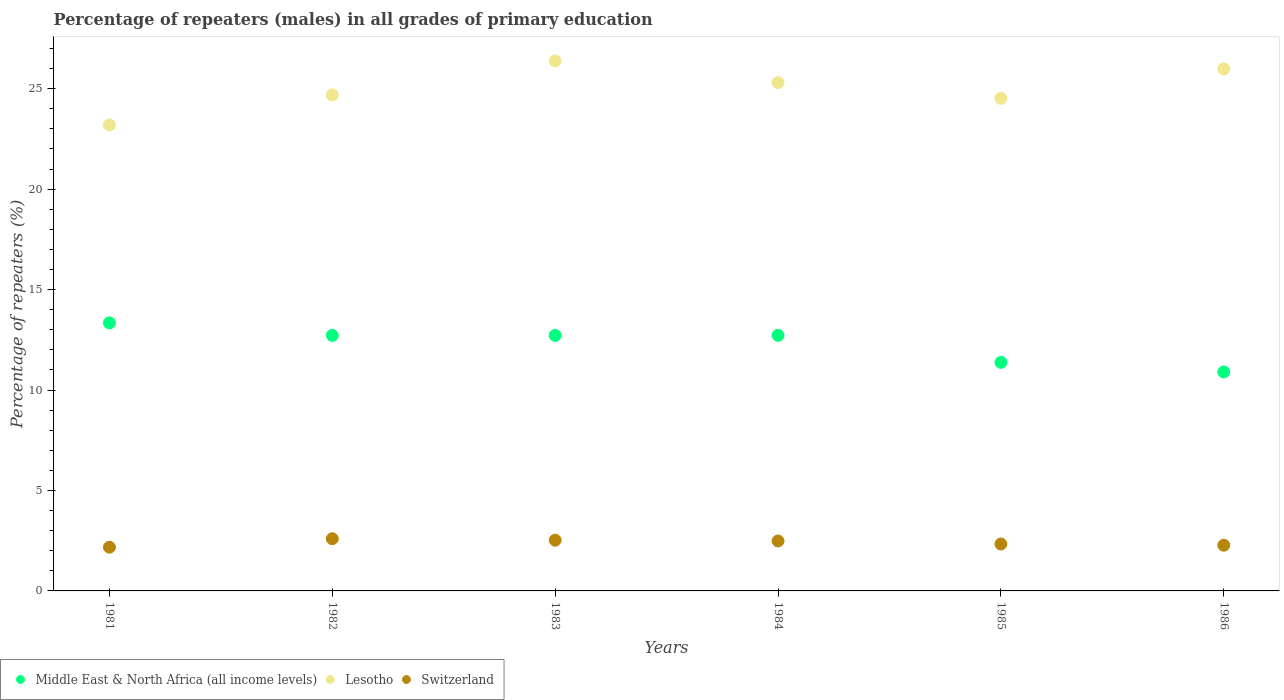Is the number of dotlines equal to the number of legend labels?
Make the answer very short. Yes. What is the percentage of repeaters (males) in Lesotho in 1981?
Your response must be concise. 23.2. Across all years, what is the maximum percentage of repeaters (males) in Switzerland?
Provide a short and direct response. 2.6. Across all years, what is the minimum percentage of repeaters (males) in Lesotho?
Your answer should be compact. 23.2. In which year was the percentage of repeaters (males) in Lesotho maximum?
Make the answer very short. 1983. What is the total percentage of repeaters (males) in Switzerland in the graph?
Keep it short and to the point. 14.4. What is the difference between the percentage of repeaters (males) in Switzerland in 1981 and that in 1985?
Offer a very short reply. -0.16. What is the difference between the percentage of repeaters (males) in Lesotho in 1985 and the percentage of repeaters (males) in Middle East & North Africa (all income levels) in 1981?
Make the answer very short. 11.18. What is the average percentage of repeaters (males) in Middle East & North Africa (all income levels) per year?
Give a very brief answer. 12.3. In the year 1986, what is the difference between the percentage of repeaters (males) in Lesotho and percentage of repeaters (males) in Middle East & North Africa (all income levels)?
Your answer should be very brief. 15.08. What is the ratio of the percentage of repeaters (males) in Switzerland in 1981 to that in 1986?
Give a very brief answer. 0.96. Is the percentage of repeaters (males) in Lesotho in 1985 less than that in 1986?
Provide a short and direct response. Yes. Is the difference between the percentage of repeaters (males) in Lesotho in 1983 and 1986 greater than the difference between the percentage of repeaters (males) in Middle East & North Africa (all income levels) in 1983 and 1986?
Provide a succinct answer. No. What is the difference between the highest and the second highest percentage of repeaters (males) in Lesotho?
Your response must be concise. 0.4. What is the difference between the highest and the lowest percentage of repeaters (males) in Middle East & North Africa (all income levels)?
Provide a succinct answer. 2.44. In how many years, is the percentage of repeaters (males) in Middle East & North Africa (all income levels) greater than the average percentage of repeaters (males) in Middle East & North Africa (all income levels) taken over all years?
Provide a short and direct response. 4. Is it the case that in every year, the sum of the percentage of repeaters (males) in Switzerland and percentage of repeaters (males) in Middle East & North Africa (all income levels)  is greater than the percentage of repeaters (males) in Lesotho?
Give a very brief answer. No. Does the percentage of repeaters (males) in Middle East & North Africa (all income levels) monotonically increase over the years?
Keep it short and to the point. No. Is the percentage of repeaters (males) in Lesotho strictly greater than the percentage of repeaters (males) in Middle East & North Africa (all income levels) over the years?
Your answer should be compact. Yes. Is the percentage of repeaters (males) in Middle East & North Africa (all income levels) strictly less than the percentage of repeaters (males) in Lesotho over the years?
Provide a succinct answer. Yes. How many dotlines are there?
Your response must be concise. 3. What is the difference between two consecutive major ticks on the Y-axis?
Your answer should be very brief. 5. Are the values on the major ticks of Y-axis written in scientific E-notation?
Your answer should be compact. No. Where does the legend appear in the graph?
Provide a succinct answer. Bottom left. How many legend labels are there?
Provide a succinct answer. 3. What is the title of the graph?
Give a very brief answer. Percentage of repeaters (males) in all grades of primary education. Does "Papua New Guinea" appear as one of the legend labels in the graph?
Give a very brief answer. No. What is the label or title of the X-axis?
Provide a succinct answer. Years. What is the label or title of the Y-axis?
Ensure brevity in your answer.  Percentage of repeaters (%). What is the Percentage of repeaters (%) in Middle East & North Africa (all income levels) in 1981?
Offer a very short reply. 13.34. What is the Percentage of repeaters (%) in Lesotho in 1981?
Provide a short and direct response. 23.2. What is the Percentage of repeaters (%) in Switzerland in 1981?
Make the answer very short. 2.18. What is the Percentage of repeaters (%) of Middle East & North Africa (all income levels) in 1982?
Offer a terse response. 12.72. What is the Percentage of repeaters (%) in Lesotho in 1982?
Keep it short and to the point. 24.69. What is the Percentage of repeaters (%) of Switzerland in 1982?
Keep it short and to the point. 2.6. What is the Percentage of repeaters (%) of Middle East & North Africa (all income levels) in 1983?
Give a very brief answer. 12.72. What is the Percentage of repeaters (%) in Lesotho in 1983?
Provide a succinct answer. 26.39. What is the Percentage of repeaters (%) of Switzerland in 1983?
Provide a short and direct response. 2.53. What is the Percentage of repeaters (%) in Middle East & North Africa (all income levels) in 1984?
Your answer should be very brief. 12.72. What is the Percentage of repeaters (%) of Lesotho in 1984?
Your answer should be very brief. 25.3. What is the Percentage of repeaters (%) of Switzerland in 1984?
Provide a short and direct response. 2.49. What is the Percentage of repeaters (%) in Middle East & North Africa (all income levels) in 1985?
Provide a succinct answer. 11.38. What is the Percentage of repeaters (%) of Lesotho in 1985?
Keep it short and to the point. 24.52. What is the Percentage of repeaters (%) of Switzerland in 1985?
Ensure brevity in your answer.  2.34. What is the Percentage of repeaters (%) in Middle East & North Africa (all income levels) in 1986?
Ensure brevity in your answer.  10.9. What is the Percentage of repeaters (%) of Lesotho in 1986?
Give a very brief answer. 25.98. What is the Percentage of repeaters (%) of Switzerland in 1986?
Your answer should be very brief. 2.28. Across all years, what is the maximum Percentage of repeaters (%) in Middle East & North Africa (all income levels)?
Provide a succinct answer. 13.34. Across all years, what is the maximum Percentage of repeaters (%) of Lesotho?
Make the answer very short. 26.39. Across all years, what is the maximum Percentage of repeaters (%) in Switzerland?
Offer a very short reply. 2.6. Across all years, what is the minimum Percentage of repeaters (%) in Middle East & North Africa (all income levels)?
Offer a very short reply. 10.9. Across all years, what is the minimum Percentage of repeaters (%) in Lesotho?
Your answer should be compact. 23.2. Across all years, what is the minimum Percentage of repeaters (%) of Switzerland?
Your answer should be compact. 2.18. What is the total Percentage of repeaters (%) of Middle East & North Africa (all income levels) in the graph?
Provide a succinct answer. 73.78. What is the total Percentage of repeaters (%) of Lesotho in the graph?
Offer a very short reply. 150.08. What is the total Percentage of repeaters (%) of Switzerland in the graph?
Give a very brief answer. 14.4. What is the difference between the Percentage of repeaters (%) in Middle East & North Africa (all income levels) in 1981 and that in 1982?
Keep it short and to the point. 0.62. What is the difference between the Percentage of repeaters (%) in Lesotho in 1981 and that in 1982?
Keep it short and to the point. -1.5. What is the difference between the Percentage of repeaters (%) in Switzerland in 1981 and that in 1982?
Make the answer very short. -0.42. What is the difference between the Percentage of repeaters (%) of Middle East & North Africa (all income levels) in 1981 and that in 1983?
Give a very brief answer. 0.62. What is the difference between the Percentage of repeaters (%) of Lesotho in 1981 and that in 1983?
Ensure brevity in your answer.  -3.19. What is the difference between the Percentage of repeaters (%) in Switzerland in 1981 and that in 1983?
Give a very brief answer. -0.35. What is the difference between the Percentage of repeaters (%) in Middle East & North Africa (all income levels) in 1981 and that in 1984?
Ensure brevity in your answer.  0.62. What is the difference between the Percentage of repeaters (%) of Lesotho in 1981 and that in 1984?
Your answer should be compact. -2.11. What is the difference between the Percentage of repeaters (%) of Switzerland in 1981 and that in 1984?
Provide a short and direct response. -0.31. What is the difference between the Percentage of repeaters (%) of Middle East & North Africa (all income levels) in 1981 and that in 1985?
Your answer should be very brief. 1.96. What is the difference between the Percentage of repeaters (%) of Lesotho in 1981 and that in 1985?
Offer a very short reply. -1.33. What is the difference between the Percentage of repeaters (%) of Switzerland in 1981 and that in 1985?
Your answer should be compact. -0.16. What is the difference between the Percentage of repeaters (%) of Middle East & North Africa (all income levels) in 1981 and that in 1986?
Your answer should be compact. 2.44. What is the difference between the Percentage of repeaters (%) in Lesotho in 1981 and that in 1986?
Your response must be concise. -2.79. What is the difference between the Percentage of repeaters (%) in Switzerland in 1981 and that in 1986?
Provide a short and direct response. -0.1. What is the difference between the Percentage of repeaters (%) of Middle East & North Africa (all income levels) in 1982 and that in 1983?
Offer a very short reply. 0. What is the difference between the Percentage of repeaters (%) in Lesotho in 1982 and that in 1983?
Ensure brevity in your answer.  -1.69. What is the difference between the Percentage of repeaters (%) of Switzerland in 1982 and that in 1983?
Make the answer very short. 0.07. What is the difference between the Percentage of repeaters (%) in Middle East & North Africa (all income levels) in 1982 and that in 1984?
Make the answer very short. -0. What is the difference between the Percentage of repeaters (%) of Lesotho in 1982 and that in 1984?
Give a very brief answer. -0.61. What is the difference between the Percentage of repeaters (%) of Switzerland in 1982 and that in 1984?
Your answer should be compact. 0.11. What is the difference between the Percentage of repeaters (%) in Middle East & North Africa (all income levels) in 1982 and that in 1985?
Provide a short and direct response. 1.34. What is the difference between the Percentage of repeaters (%) of Lesotho in 1982 and that in 1985?
Your answer should be very brief. 0.17. What is the difference between the Percentage of repeaters (%) of Switzerland in 1982 and that in 1985?
Your response must be concise. 0.26. What is the difference between the Percentage of repeaters (%) of Middle East & North Africa (all income levels) in 1982 and that in 1986?
Your response must be concise. 1.82. What is the difference between the Percentage of repeaters (%) in Lesotho in 1982 and that in 1986?
Provide a succinct answer. -1.29. What is the difference between the Percentage of repeaters (%) of Switzerland in 1982 and that in 1986?
Offer a terse response. 0.32. What is the difference between the Percentage of repeaters (%) in Middle East & North Africa (all income levels) in 1983 and that in 1984?
Provide a succinct answer. -0.01. What is the difference between the Percentage of repeaters (%) in Lesotho in 1983 and that in 1984?
Provide a short and direct response. 1.08. What is the difference between the Percentage of repeaters (%) of Switzerland in 1983 and that in 1984?
Offer a terse response. 0.04. What is the difference between the Percentage of repeaters (%) of Middle East & North Africa (all income levels) in 1983 and that in 1985?
Your response must be concise. 1.34. What is the difference between the Percentage of repeaters (%) of Lesotho in 1983 and that in 1985?
Your answer should be very brief. 1.86. What is the difference between the Percentage of repeaters (%) of Switzerland in 1983 and that in 1985?
Provide a succinct answer. 0.19. What is the difference between the Percentage of repeaters (%) of Middle East & North Africa (all income levels) in 1983 and that in 1986?
Your answer should be very brief. 1.82. What is the difference between the Percentage of repeaters (%) in Lesotho in 1983 and that in 1986?
Give a very brief answer. 0.4. What is the difference between the Percentage of repeaters (%) in Switzerland in 1983 and that in 1986?
Keep it short and to the point. 0.25. What is the difference between the Percentage of repeaters (%) of Middle East & North Africa (all income levels) in 1984 and that in 1985?
Keep it short and to the point. 1.35. What is the difference between the Percentage of repeaters (%) in Lesotho in 1984 and that in 1985?
Give a very brief answer. 0.78. What is the difference between the Percentage of repeaters (%) of Switzerland in 1984 and that in 1985?
Give a very brief answer. 0.15. What is the difference between the Percentage of repeaters (%) of Middle East & North Africa (all income levels) in 1984 and that in 1986?
Provide a succinct answer. 1.82. What is the difference between the Percentage of repeaters (%) of Lesotho in 1984 and that in 1986?
Offer a terse response. -0.68. What is the difference between the Percentage of repeaters (%) in Switzerland in 1984 and that in 1986?
Your answer should be compact. 0.21. What is the difference between the Percentage of repeaters (%) of Middle East & North Africa (all income levels) in 1985 and that in 1986?
Your answer should be compact. 0.48. What is the difference between the Percentage of repeaters (%) of Lesotho in 1985 and that in 1986?
Your answer should be compact. -1.46. What is the difference between the Percentage of repeaters (%) of Switzerland in 1985 and that in 1986?
Your answer should be compact. 0.06. What is the difference between the Percentage of repeaters (%) of Middle East & North Africa (all income levels) in 1981 and the Percentage of repeaters (%) of Lesotho in 1982?
Provide a short and direct response. -11.35. What is the difference between the Percentage of repeaters (%) in Middle East & North Africa (all income levels) in 1981 and the Percentage of repeaters (%) in Switzerland in 1982?
Provide a short and direct response. 10.74. What is the difference between the Percentage of repeaters (%) of Lesotho in 1981 and the Percentage of repeaters (%) of Switzerland in 1982?
Provide a short and direct response. 20.6. What is the difference between the Percentage of repeaters (%) in Middle East & North Africa (all income levels) in 1981 and the Percentage of repeaters (%) in Lesotho in 1983?
Give a very brief answer. -13.04. What is the difference between the Percentage of repeaters (%) in Middle East & North Africa (all income levels) in 1981 and the Percentage of repeaters (%) in Switzerland in 1983?
Provide a succinct answer. 10.82. What is the difference between the Percentage of repeaters (%) of Lesotho in 1981 and the Percentage of repeaters (%) of Switzerland in 1983?
Keep it short and to the point. 20.67. What is the difference between the Percentage of repeaters (%) of Middle East & North Africa (all income levels) in 1981 and the Percentage of repeaters (%) of Lesotho in 1984?
Provide a succinct answer. -11.96. What is the difference between the Percentage of repeaters (%) in Middle East & North Africa (all income levels) in 1981 and the Percentage of repeaters (%) in Switzerland in 1984?
Your response must be concise. 10.86. What is the difference between the Percentage of repeaters (%) of Lesotho in 1981 and the Percentage of repeaters (%) of Switzerland in 1984?
Provide a succinct answer. 20.71. What is the difference between the Percentage of repeaters (%) of Middle East & North Africa (all income levels) in 1981 and the Percentage of repeaters (%) of Lesotho in 1985?
Your answer should be very brief. -11.18. What is the difference between the Percentage of repeaters (%) in Middle East & North Africa (all income levels) in 1981 and the Percentage of repeaters (%) in Switzerland in 1985?
Your answer should be compact. 11.01. What is the difference between the Percentage of repeaters (%) in Lesotho in 1981 and the Percentage of repeaters (%) in Switzerland in 1985?
Offer a terse response. 20.86. What is the difference between the Percentage of repeaters (%) of Middle East & North Africa (all income levels) in 1981 and the Percentage of repeaters (%) of Lesotho in 1986?
Ensure brevity in your answer.  -12.64. What is the difference between the Percentage of repeaters (%) of Middle East & North Africa (all income levels) in 1981 and the Percentage of repeaters (%) of Switzerland in 1986?
Your answer should be very brief. 11.07. What is the difference between the Percentage of repeaters (%) in Lesotho in 1981 and the Percentage of repeaters (%) in Switzerland in 1986?
Your answer should be very brief. 20.92. What is the difference between the Percentage of repeaters (%) of Middle East & North Africa (all income levels) in 1982 and the Percentage of repeaters (%) of Lesotho in 1983?
Your answer should be compact. -13.67. What is the difference between the Percentage of repeaters (%) of Middle East & North Africa (all income levels) in 1982 and the Percentage of repeaters (%) of Switzerland in 1983?
Provide a short and direct response. 10.19. What is the difference between the Percentage of repeaters (%) in Lesotho in 1982 and the Percentage of repeaters (%) in Switzerland in 1983?
Offer a very short reply. 22.17. What is the difference between the Percentage of repeaters (%) of Middle East & North Africa (all income levels) in 1982 and the Percentage of repeaters (%) of Lesotho in 1984?
Offer a very short reply. -12.58. What is the difference between the Percentage of repeaters (%) in Middle East & North Africa (all income levels) in 1982 and the Percentage of repeaters (%) in Switzerland in 1984?
Your answer should be very brief. 10.23. What is the difference between the Percentage of repeaters (%) of Lesotho in 1982 and the Percentage of repeaters (%) of Switzerland in 1984?
Offer a very short reply. 22.21. What is the difference between the Percentage of repeaters (%) of Middle East & North Africa (all income levels) in 1982 and the Percentage of repeaters (%) of Lesotho in 1985?
Provide a short and direct response. -11.8. What is the difference between the Percentage of repeaters (%) of Middle East & North Africa (all income levels) in 1982 and the Percentage of repeaters (%) of Switzerland in 1985?
Your answer should be compact. 10.38. What is the difference between the Percentage of repeaters (%) in Lesotho in 1982 and the Percentage of repeaters (%) in Switzerland in 1985?
Give a very brief answer. 22.36. What is the difference between the Percentage of repeaters (%) of Middle East & North Africa (all income levels) in 1982 and the Percentage of repeaters (%) of Lesotho in 1986?
Ensure brevity in your answer.  -13.26. What is the difference between the Percentage of repeaters (%) of Middle East & North Africa (all income levels) in 1982 and the Percentage of repeaters (%) of Switzerland in 1986?
Keep it short and to the point. 10.44. What is the difference between the Percentage of repeaters (%) in Lesotho in 1982 and the Percentage of repeaters (%) in Switzerland in 1986?
Your answer should be very brief. 22.42. What is the difference between the Percentage of repeaters (%) in Middle East & North Africa (all income levels) in 1983 and the Percentage of repeaters (%) in Lesotho in 1984?
Give a very brief answer. -12.58. What is the difference between the Percentage of repeaters (%) of Middle East & North Africa (all income levels) in 1983 and the Percentage of repeaters (%) of Switzerland in 1984?
Your answer should be compact. 10.23. What is the difference between the Percentage of repeaters (%) of Lesotho in 1983 and the Percentage of repeaters (%) of Switzerland in 1984?
Provide a succinct answer. 23.9. What is the difference between the Percentage of repeaters (%) in Middle East & North Africa (all income levels) in 1983 and the Percentage of repeaters (%) in Lesotho in 1985?
Give a very brief answer. -11.8. What is the difference between the Percentage of repeaters (%) in Middle East & North Africa (all income levels) in 1983 and the Percentage of repeaters (%) in Switzerland in 1985?
Make the answer very short. 10.38. What is the difference between the Percentage of repeaters (%) in Lesotho in 1983 and the Percentage of repeaters (%) in Switzerland in 1985?
Keep it short and to the point. 24.05. What is the difference between the Percentage of repeaters (%) of Middle East & North Africa (all income levels) in 1983 and the Percentage of repeaters (%) of Lesotho in 1986?
Provide a succinct answer. -13.27. What is the difference between the Percentage of repeaters (%) in Middle East & North Africa (all income levels) in 1983 and the Percentage of repeaters (%) in Switzerland in 1986?
Ensure brevity in your answer.  10.44. What is the difference between the Percentage of repeaters (%) in Lesotho in 1983 and the Percentage of repeaters (%) in Switzerland in 1986?
Your response must be concise. 24.11. What is the difference between the Percentage of repeaters (%) of Middle East & North Africa (all income levels) in 1984 and the Percentage of repeaters (%) of Lesotho in 1985?
Ensure brevity in your answer.  -11.8. What is the difference between the Percentage of repeaters (%) of Middle East & North Africa (all income levels) in 1984 and the Percentage of repeaters (%) of Switzerland in 1985?
Ensure brevity in your answer.  10.39. What is the difference between the Percentage of repeaters (%) in Lesotho in 1984 and the Percentage of repeaters (%) in Switzerland in 1985?
Provide a succinct answer. 22.97. What is the difference between the Percentage of repeaters (%) of Middle East & North Africa (all income levels) in 1984 and the Percentage of repeaters (%) of Lesotho in 1986?
Keep it short and to the point. -13.26. What is the difference between the Percentage of repeaters (%) of Middle East & North Africa (all income levels) in 1984 and the Percentage of repeaters (%) of Switzerland in 1986?
Provide a succinct answer. 10.45. What is the difference between the Percentage of repeaters (%) in Lesotho in 1984 and the Percentage of repeaters (%) in Switzerland in 1986?
Your response must be concise. 23.03. What is the difference between the Percentage of repeaters (%) of Middle East & North Africa (all income levels) in 1985 and the Percentage of repeaters (%) of Lesotho in 1986?
Ensure brevity in your answer.  -14.61. What is the difference between the Percentage of repeaters (%) in Middle East & North Africa (all income levels) in 1985 and the Percentage of repeaters (%) in Switzerland in 1986?
Keep it short and to the point. 9.1. What is the difference between the Percentage of repeaters (%) of Lesotho in 1985 and the Percentage of repeaters (%) of Switzerland in 1986?
Ensure brevity in your answer.  22.25. What is the average Percentage of repeaters (%) of Middle East & North Africa (all income levels) per year?
Offer a terse response. 12.3. What is the average Percentage of repeaters (%) of Lesotho per year?
Your response must be concise. 25.01. In the year 1981, what is the difference between the Percentage of repeaters (%) of Middle East & North Africa (all income levels) and Percentage of repeaters (%) of Lesotho?
Keep it short and to the point. -9.85. In the year 1981, what is the difference between the Percentage of repeaters (%) of Middle East & North Africa (all income levels) and Percentage of repeaters (%) of Switzerland?
Your answer should be compact. 11.17. In the year 1981, what is the difference between the Percentage of repeaters (%) in Lesotho and Percentage of repeaters (%) in Switzerland?
Your answer should be very brief. 21.02. In the year 1982, what is the difference between the Percentage of repeaters (%) in Middle East & North Africa (all income levels) and Percentage of repeaters (%) in Lesotho?
Provide a short and direct response. -11.97. In the year 1982, what is the difference between the Percentage of repeaters (%) in Middle East & North Africa (all income levels) and Percentage of repeaters (%) in Switzerland?
Your answer should be very brief. 10.12. In the year 1982, what is the difference between the Percentage of repeaters (%) of Lesotho and Percentage of repeaters (%) of Switzerland?
Give a very brief answer. 22.09. In the year 1983, what is the difference between the Percentage of repeaters (%) of Middle East & North Africa (all income levels) and Percentage of repeaters (%) of Lesotho?
Make the answer very short. -13.67. In the year 1983, what is the difference between the Percentage of repeaters (%) in Middle East & North Africa (all income levels) and Percentage of repeaters (%) in Switzerland?
Provide a succinct answer. 10.19. In the year 1983, what is the difference between the Percentage of repeaters (%) of Lesotho and Percentage of repeaters (%) of Switzerland?
Ensure brevity in your answer.  23.86. In the year 1984, what is the difference between the Percentage of repeaters (%) in Middle East & North Africa (all income levels) and Percentage of repeaters (%) in Lesotho?
Offer a terse response. -12.58. In the year 1984, what is the difference between the Percentage of repeaters (%) of Middle East & North Africa (all income levels) and Percentage of repeaters (%) of Switzerland?
Give a very brief answer. 10.24. In the year 1984, what is the difference between the Percentage of repeaters (%) of Lesotho and Percentage of repeaters (%) of Switzerland?
Your answer should be compact. 22.82. In the year 1985, what is the difference between the Percentage of repeaters (%) in Middle East & North Africa (all income levels) and Percentage of repeaters (%) in Lesotho?
Provide a succinct answer. -13.14. In the year 1985, what is the difference between the Percentage of repeaters (%) in Middle East & North Africa (all income levels) and Percentage of repeaters (%) in Switzerland?
Ensure brevity in your answer.  9.04. In the year 1985, what is the difference between the Percentage of repeaters (%) in Lesotho and Percentage of repeaters (%) in Switzerland?
Your response must be concise. 22.19. In the year 1986, what is the difference between the Percentage of repeaters (%) of Middle East & North Africa (all income levels) and Percentage of repeaters (%) of Lesotho?
Make the answer very short. -15.08. In the year 1986, what is the difference between the Percentage of repeaters (%) of Middle East & North Africa (all income levels) and Percentage of repeaters (%) of Switzerland?
Provide a short and direct response. 8.62. In the year 1986, what is the difference between the Percentage of repeaters (%) in Lesotho and Percentage of repeaters (%) in Switzerland?
Provide a short and direct response. 23.71. What is the ratio of the Percentage of repeaters (%) in Middle East & North Africa (all income levels) in 1981 to that in 1982?
Make the answer very short. 1.05. What is the ratio of the Percentage of repeaters (%) in Lesotho in 1981 to that in 1982?
Your answer should be compact. 0.94. What is the ratio of the Percentage of repeaters (%) of Switzerland in 1981 to that in 1982?
Give a very brief answer. 0.84. What is the ratio of the Percentage of repeaters (%) in Middle East & North Africa (all income levels) in 1981 to that in 1983?
Make the answer very short. 1.05. What is the ratio of the Percentage of repeaters (%) in Lesotho in 1981 to that in 1983?
Keep it short and to the point. 0.88. What is the ratio of the Percentage of repeaters (%) of Switzerland in 1981 to that in 1983?
Ensure brevity in your answer.  0.86. What is the ratio of the Percentage of repeaters (%) of Middle East & North Africa (all income levels) in 1981 to that in 1984?
Provide a short and direct response. 1.05. What is the ratio of the Percentage of repeaters (%) in Lesotho in 1981 to that in 1984?
Offer a terse response. 0.92. What is the ratio of the Percentage of repeaters (%) in Switzerland in 1981 to that in 1984?
Ensure brevity in your answer.  0.87. What is the ratio of the Percentage of repeaters (%) of Middle East & North Africa (all income levels) in 1981 to that in 1985?
Offer a terse response. 1.17. What is the ratio of the Percentage of repeaters (%) in Lesotho in 1981 to that in 1985?
Make the answer very short. 0.95. What is the ratio of the Percentage of repeaters (%) in Switzerland in 1981 to that in 1985?
Ensure brevity in your answer.  0.93. What is the ratio of the Percentage of repeaters (%) in Middle East & North Africa (all income levels) in 1981 to that in 1986?
Keep it short and to the point. 1.22. What is the ratio of the Percentage of repeaters (%) of Lesotho in 1981 to that in 1986?
Give a very brief answer. 0.89. What is the ratio of the Percentage of repeaters (%) in Switzerland in 1981 to that in 1986?
Your response must be concise. 0.96. What is the ratio of the Percentage of repeaters (%) in Lesotho in 1982 to that in 1983?
Ensure brevity in your answer.  0.94. What is the ratio of the Percentage of repeaters (%) in Switzerland in 1982 to that in 1983?
Your response must be concise. 1.03. What is the ratio of the Percentage of repeaters (%) of Lesotho in 1982 to that in 1984?
Give a very brief answer. 0.98. What is the ratio of the Percentage of repeaters (%) in Switzerland in 1982 to that in 1984?
Make the answer very short. 1.04. What is the ratio of the Percentage of repeaters (%) in Middle East & North Africa (all income levels) in 1982 to that in 1985?
Give a very brief answer. 1.12. What is the ratio of the Percentage of repeaters (%) in Lesotho in 1982 to that in 1985?
Give a very brief answer. 1.01. What is the ratio of the Percentage of repeaters (%) in Switzerland in 1982 to that in 1985?
Give a very brief answer. 1.11. What is the ratio of the Percentage of repeaters (%) of Middle East & North Africa (all income levels) in 1982 to that in 1986?
Give a very brief answer. 1.17. What is the ratio of the Percentage of repeaters (%) in Lesotho in 1982 to that in 1986?
Your answer should be compact. 0.95. What is the ratio of the Percentage of repeaters (%) in Switzerland in 1982 to that in 1986?
Ensure brevity in your answer.  1.14. What is the ratio of the Percentage of repeaters (%) of Middle East & North Africa (all income levels) in 1983 to that in 1984?
Offer a terse response. 1. What is the ratio of the Percentage of repeaters (%) in Lesotho in 1983 to that in 1984?
Your answer should be very brief. 1.04. What is the ratio of the Percentage of repeaters (%) of Switzerland in 1983 to that in 1984?
Your answer should be compact. 1.02. What is the ratio of the Percentage of repeaters (%) in Middle East & North Africa (all income levels) in 1983 to that in 1985?
Your response must be concise. 1.12. What is the ratio of the Percentage of repeaters (%) of Lesotho in 1983 to that in 1985?
Your answer should be compact. 1.08. What is the ratio of the Percentage of repeaters (%) of Switzerland in 1983 to that in 1985?
Ensure brevity in your answer.  1.08. What is the ratio of the Percentage of repeaters (%) in Middle East & North Africa (all income levels) in 1983 to that in 1986?
Provide a short and direct response. 1.17. What is the ratio of the Percentage of repeaters (%) in Lesotho in 1983 to that in 1986?
Your response must be concise. 1.02. What is the ratio of the Percentage of repeaters (%) in Switzerland in 1983 to that in 1986?
Your answer should be compact. 1.11. What is the ratio of the Percentage of repeaters (%) in Middle East & North Africa (all income levels) in 1984 to that in 1985?
Offer a very short reply. 1.12. What is the ratio of the Percentage of repeaters (%) of Lesotho in 1984 to that in 1985?
Your answer should be very brief. 1.03. What is the ratio of the Percentage of repeaters (%) in Switzerland in 1984 to that in 1985?
Give a very brief answer. 1.06. What is the ratio of the Percentage of repeaters (%) of Middle East & North Africa (all income levels) in 1984 to that in 1986?
Offer a terse response. 1.17. What is the ratio of the Percentage of repeaters (%) of Lesotho in 1984 to that in 1986?
Your answer should be compact. 0.97. What is the ratio of the Percentage of repeaters (%) in Switzerland in 1984 to that in 1986?
Keep it short and to the point. 1.09. What is the ratio of the Percentage of repeaters (%) in Middle East & North Africa (all income levels) in 1985 to that in 1986?
Give a very brief answer. 1.04. What is the ratio of the Percentage of repeaters (%) of Lesotho in 1985 to that in 1986?
Offer a very short reply. 0.94. What is the ratio of the Percentage of repeaters (%) in Switzerland in 1985 to that in 1986?
Provide a succinct answer. 1.03. What is the difference between the highest and the second highest Percentage of repeaters (%) in Middle East & North Africa (all income levels)?
Make the answer very short. 0.62. What is the difference between the highest and the second highest Percentage of repeaters (%) in Lesotho?
Make the answer very short. 0.4. What is the difference between the highest and the second highest Percentage of repeaters (%) of Switzerland?
Give a very brief answer. 0.07. What is the difference between the highest and the lowest Percentage of repeaters (%) in Middle East & North Africa (all income levels)?
Your answer should be compact. 2.44. What is the difference between the highest and the lowest Percentage of repeaters (%) in Lesotho?
Your answer should be very brief. 3.19. What is the difference between the highest and the lowest Percentage of repeaters (%) in Switzerland?
Ensure brevity in your answer.  0.42. 